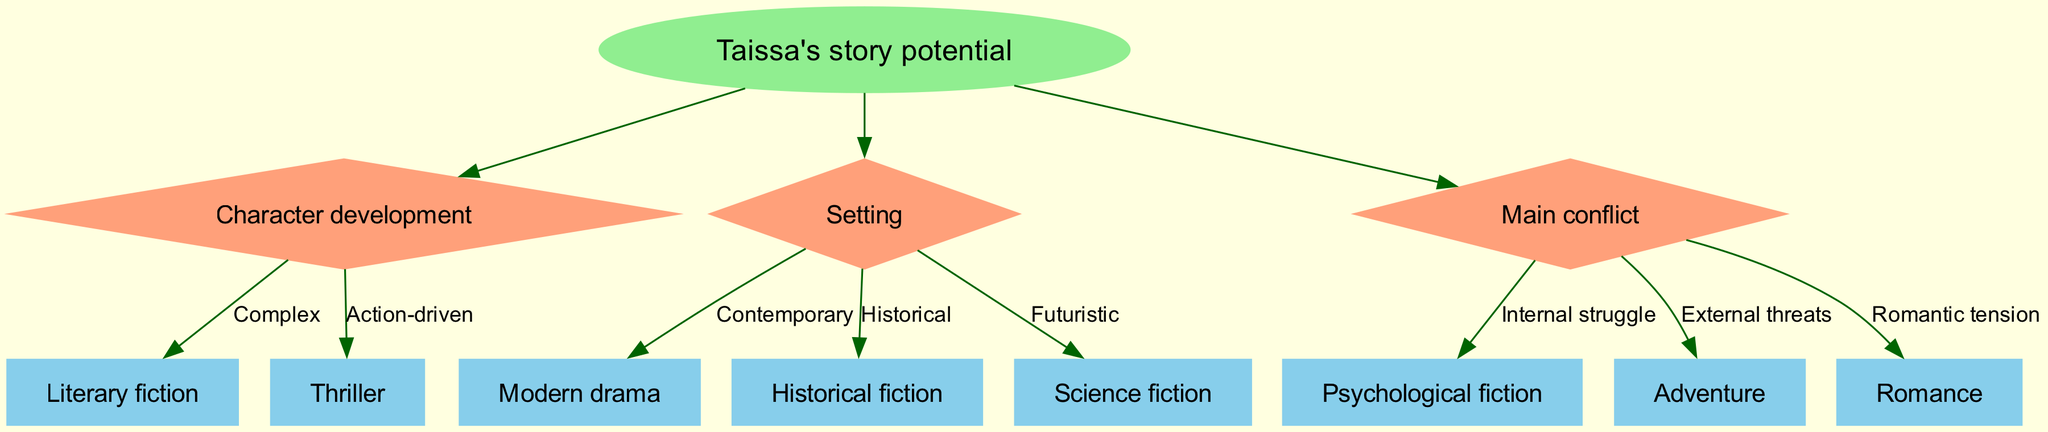What is the root node of the diagram? The root node is labeled "Taissa's story potential," which represents the main theme or focus of the decision tree. It is the starting point from which all branches and decisions unfold.
Answer: Taissa's story potential How many branches are there in the diagram? The diagram contains three branches, each representing a different aspect of the decision-making process related to writing genres. The branches are Character development, Setting, and Main conflict.
Answer: 3 What genre is associated with "Complex" character development? According to the diagram, "Complex" character development leads to the genre "Literary fiction." This connects the type of character development to a specific genre.
Answer: Literary fiction What setting corresponds to "Futuristic"? The setting labeled "Futuristic" is linked to the genre "Science fiction," indicating that stories with futuristic settings fit into this genre category.
Answer: Science fiction Which genre is chosen if the main conflict involves "Romantic tension"? The diagram specifies that if the main conflict revolves around "Romantic tension," the corresponding genre is "Romance." This establishes a direct relationship between conflict type and genre.
Answer: Romance If Taissa's story has an "Internal struggle" as the main conflict, what genre does it lead to? In the decision tree, "Internal struggle" as the main conflict leads to "Psychological fiction." This shows how the nature of the conflict directs the choice of genre.
Answer: Psychological fiction What type of character development corresponds with the genre "Thriller"? The genre "Thriller" is linked with "Action-driven" character development in the decision tree. This implies that thrillers emphasize action over depth in character development.
Answer: Action-driven How does the diagram differentiate between genres based on setting? The diagram differentiates genres based on setting by presenting distinct options such as Contemporary, Historical, and Futuristic, each leading to unique genres like Modern drama, Historical fiction, and Science fiction, respectively. This segregation by setting highlights the importance of context in genre selection.
Answer: By presenting distinct setting options From the "Main conflict" branch, how many options are there? There are three options under the "Main conflict" branch, which are "Internal struggle," "External threats," and "Romantic tension." Each option presents a different type of conflict that can lead to a specific genre.
Answer: 3 